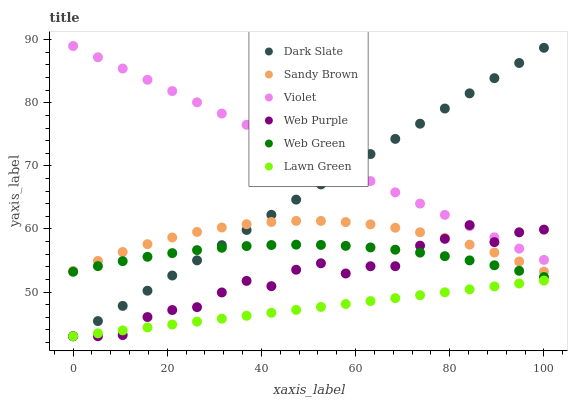Does Lawn Green have the minimum area under the curve?
Answer yes or no. Yes. Does Violet have the maximum area under the curve?
Answer yes or no. Yes. Does Web Green have the minimum area under the curve?
Answer yes or no. No. Does Web Green have the maximum area under the curve?
Answer yes or no. No. Is Lawn Green the smoothest?
Answer yes or no. Yes. Is Web Purple the roughest?
Answer yes or no. Yes. Is Web Green the smoothest?
Answer yes or no. No. Is Web Green the roughest?
Answer yes or no. No. Does Lawn Green have the lowest value?
Answer yes or no. Yes. Does Web Green have the lowest value?
Answer yes or no. No. Does Violet have the highest value?
Answer yes or no. Yes. Does Web Green have the highest value?
Answer yes or no. No. Is Lawn Green less than Sandy Brown?
Answer yes or no. Yes. Is Violet greater than Lawn Green?
Answer yes or no. Yes. Does Sandy Brown intersect Dark Slate?
Answer yes or no. Yes. Is Sandy Brown less than Dark Slate?
Answer yes or no. No. Is Sandy Brown greater than Dark Slate?
Answer yes or no. No. Does Lawn Green intersect Sandy Brown?
Answer yes or no. No. 